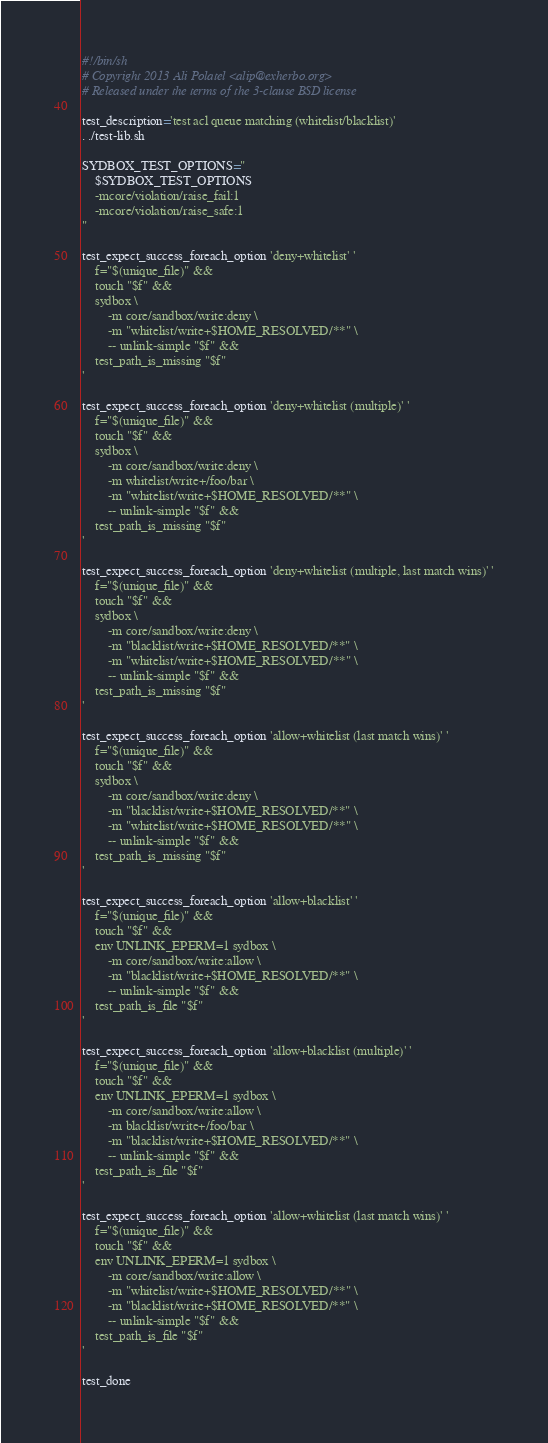Convert code to text. <code><loc_0><loc_0><loc_500><loc_500><_Bash_>#!/bin/sh
# Copyright 2013 Ali Polatel <alip@exherbo.org>
# Released under the terms of the 3-clause BSD license

test_description='test acl queue matching (whitelist/blacklist)'
. ./test-lib.sh

SYDBOX_TEST_OPTIONS="
    $SYDBOX_TEST_OPTIONS
    -mcore/violation/raise_fail:1
    -mcore/violation/raise_safe:1
"

test_expect_success_foreach_option 'deny+whitelist' '
    f="$(unique_file)" &&
    touch "$f" &&
    sydbox \
        -m core/sandbox/write:deny \
        -m "whitelist/write+$HOME_RESOLVED/**" \
        -- unlink-simple "$f" &&
    test_path_is_missing "$f"
'

test_expect_success_foreach_option 'deny+whitelist (multiple)' '
    f="$(unique_file)" &&
    touch "$f" &&
    sydbox \
        -m core/sandbox/write:deny \
        -m whitelist/write+/foo/bar \
        -m "whitelist/write+$HOME_RESOLVED/**" \
        -- unlink-simple "$f" &&
    test_path_is_missing "$f"
'

test_expect_success_foreach_option 'deny+whitelist (multiple, last match wins)' '
    f="$(unique_file)" &&
    touch "$f" &&
    sydbox \
        -m core/sandbox/write:deny \
        -m "blacklist/write+$HOME_RESOLVED/**" \
        -m "whitelist/write+$HOME_RESOLVED/**" \
        -- unlink-simple "$f" &&
    test_path_is_missing "$f"
'

test_expect_success_foreach_option 'allow+whitelist (last match wins)' '
    f="$(unique_file)" &&
    touch "$f" &&
    sydbox \
        -m core/sandbox/write:deny \
        -m "blacklist/write+$HOME_RESOLVED/**" \
        -m "whitelist/write+$HOME_RESOLVED/**" \
        -- unlink-simple "$f" &&
    test_path_is_missing "$f"
'

test_expect_success_foreach_option 'allow+blacklist' '
    f="$(unique_file)" &&
    touch "$f" &&
    env UNLINK_EPERM=1 sydbox \
        -m core/sandbox/write:allow \
        -m "blacklist/write+$HOME_RESOLVED/**" \
        -- unlink-simple "$f" &&
    test_path_is_file "$f"
'

test_expect_success_foreach_option 'allow+blacklist (multiple)' '
    f="$(unique_file)" &&
    touch "$f" &&
    env UNLINK_EPERM=1 sydbox \
        -m core/sandbox/write:allow \
        -m blacklist/write+/foo/bar \
        -m "blacklist/write+$HOME_RESOLVED/**" \
        -- unlink-simple "$f" &&
    test_path_is_file "$f"
'

test_expect_success_foreach_option 'allow+whitelist (last match wins)' '
    f="$(unique_file)" &&
    touch "$f" &&
    env UNLINK_EPERM=1 sydbox \
        -m core/sandbox/write:allow \
        -m "whitelist/write+$HOME_RESOLVED/**" \
        -m "blacklist/write+$HOME_RESOLVED/**" \
        -- unlink-simple "$f" &&
    test_path_is_file "$f"
'

test_done
</code> 